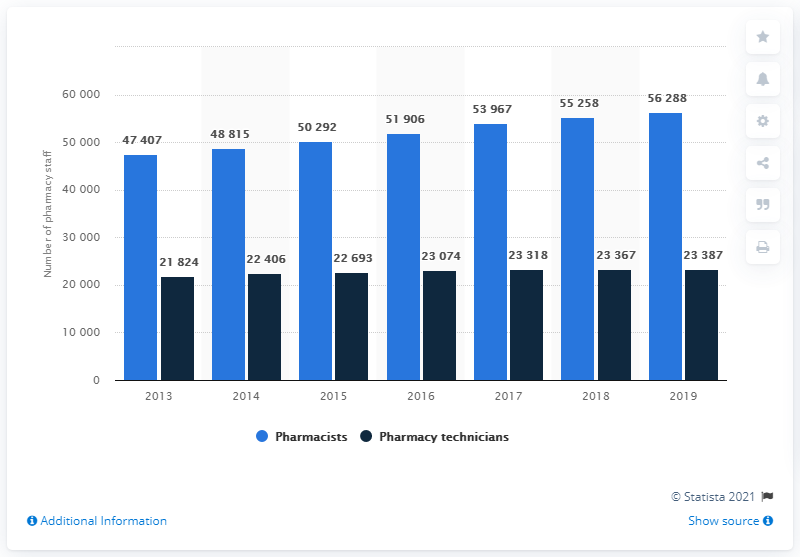Specify some key components in this picture. The number of pharmacists is expected to reach its peak in 2019. The number of pharmacists is over 51,500 and there are four times this amount. 